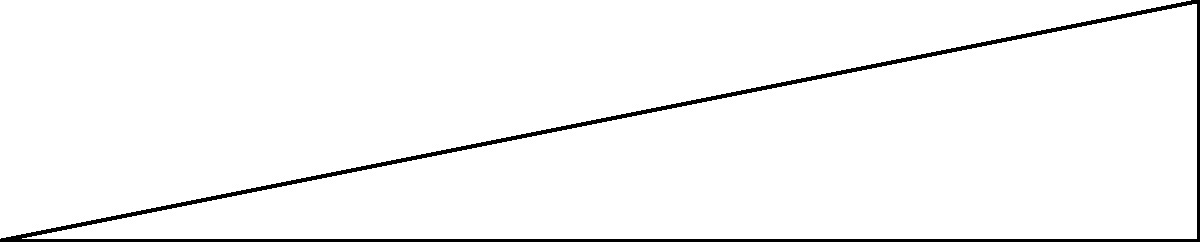As a property owner in Chicago, you're planning to install a ramp for your building to comply with ADA accessibility standards. The ramp needs to rise 20 feet over a horizontal distance of 100 feet. What is the angle of inclination ($\theta$) of this ramp? To find the angle of inclination, we can use the tangent function from trigonometry. Here's how:

1) In a right triangle, $\tan(\theta) = \frac{\text{opposite}}{\text{adjacent}}$

2) In this case:
   - The opposite side (rise) is 20 feet
   - The adjacent side (run) is 100 feet

3) So, we can write:
   $\tan(\theta) = \frac{20}{100} = 0.2$

4) To find $\theta$, we need to use the inverse tangent (arctan or $\tan^{-1}$):
   $\theta = \tan^{-1}(0.2)$

5) Using a calculator or trigonometric tables:
   $\theta \approx 11.31°$

6) Round to the nearest degree:
   $\theta \approx 11°$

This angle is indeed compliant with ADA standards, which require a maximum slope of 1:12 (about 4.8°) for new constructions and allow up to 1:8 (about 7.1°) for existing sites where space limitations make 1:12 infeasible.
Answer: $11°$ 